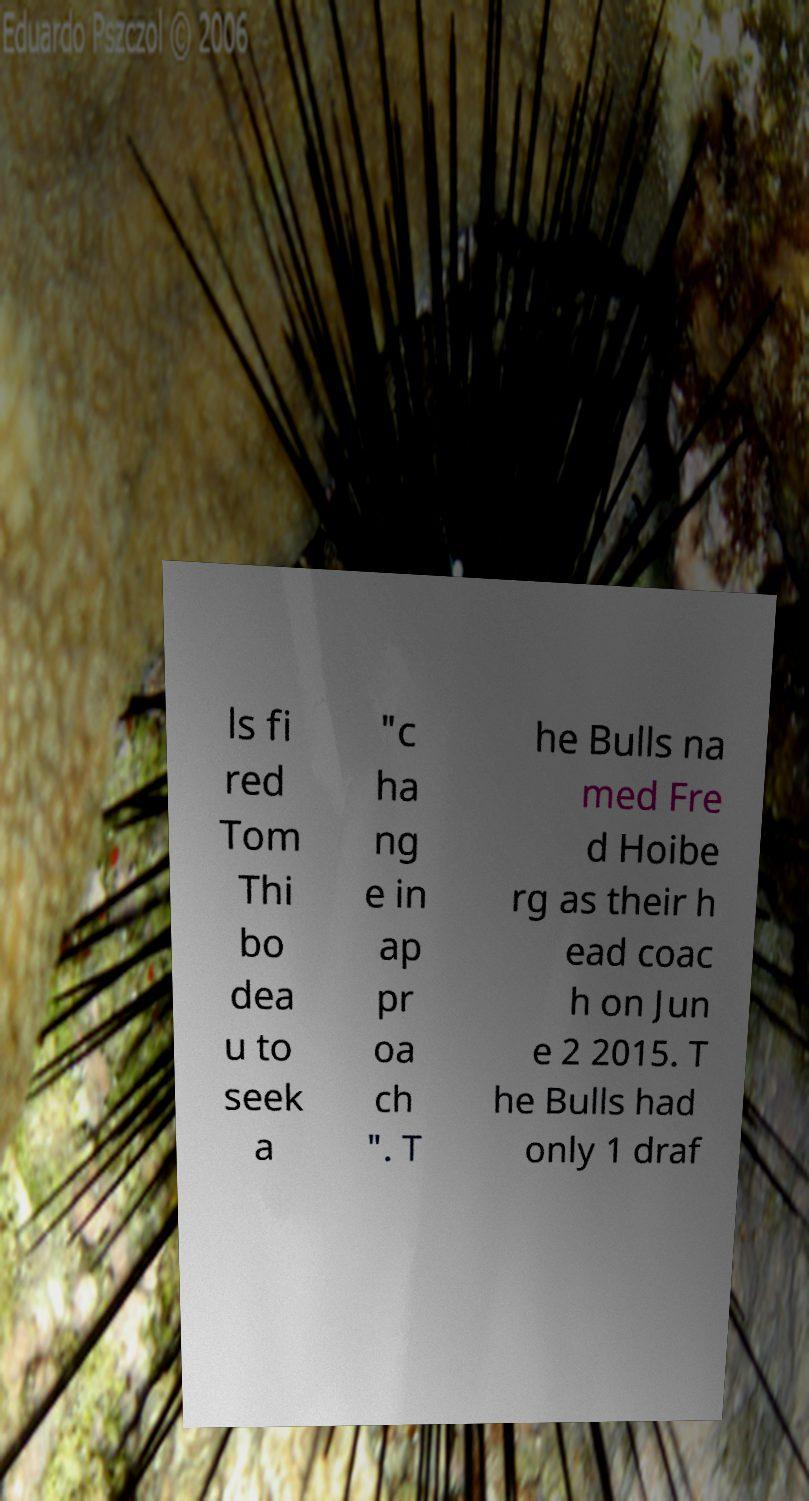Can you read and provide the text displayed in the image?This photo seems to have some interesting text. Can you extract and type it out for me? ls fi red Tom Thi bo dea u to seek a "c ha ng e in ap pr oa ch ". T he Bulls na med Fre d Hoibe rg as their h ead coac h on Jun e 2 2015. T he Bulls had only 1 draf 